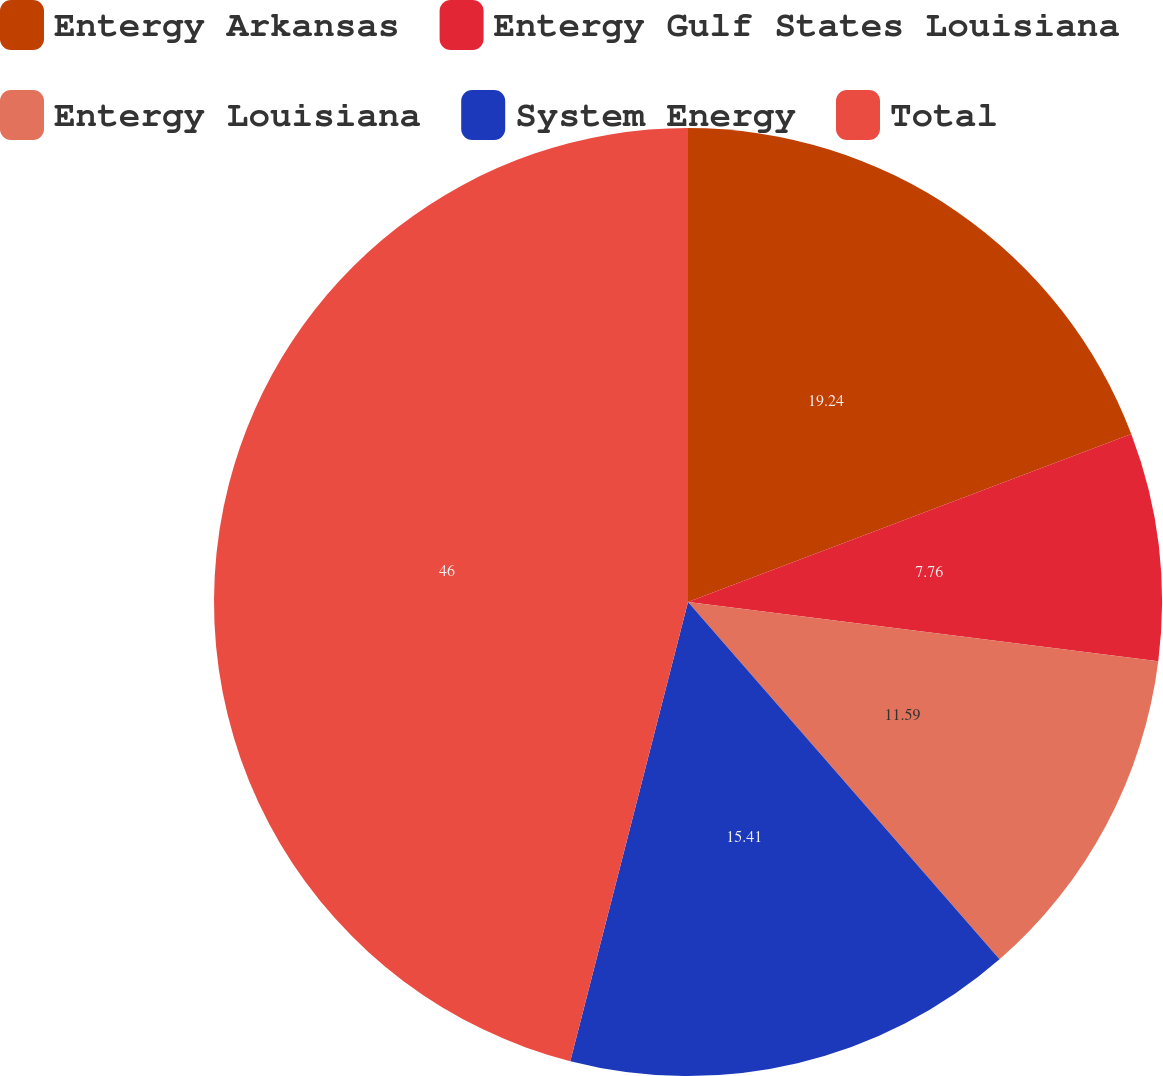Convert chart to OTSL. <chart><loc_0><loc_0><loc_500><loc_500><pie_chart><fcel>Entergy Arkansas<fcel>Entergy Gulf States Louisiana<fcel>Entergy Louisiana<fcel>System Energy<fcel>Total<nl><fcel>19.24%<fcel>7.76%<fcel>11.59%<fcel>15.41%<fcel>46.01%<nl></chart> 